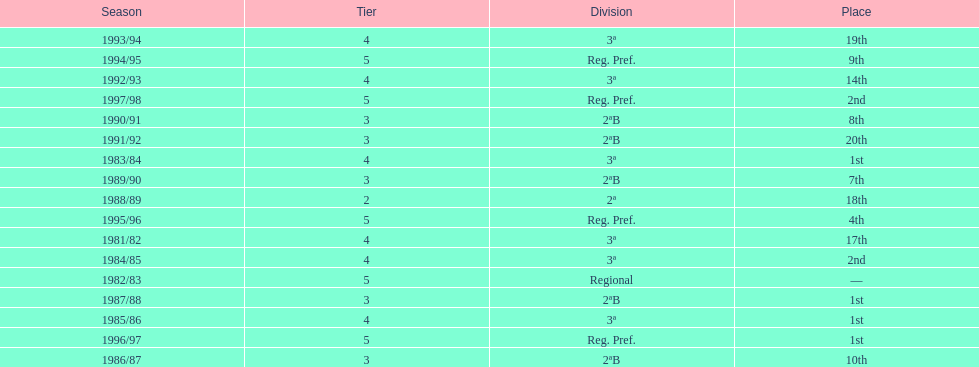What year has no place indicated? 1982/83. 